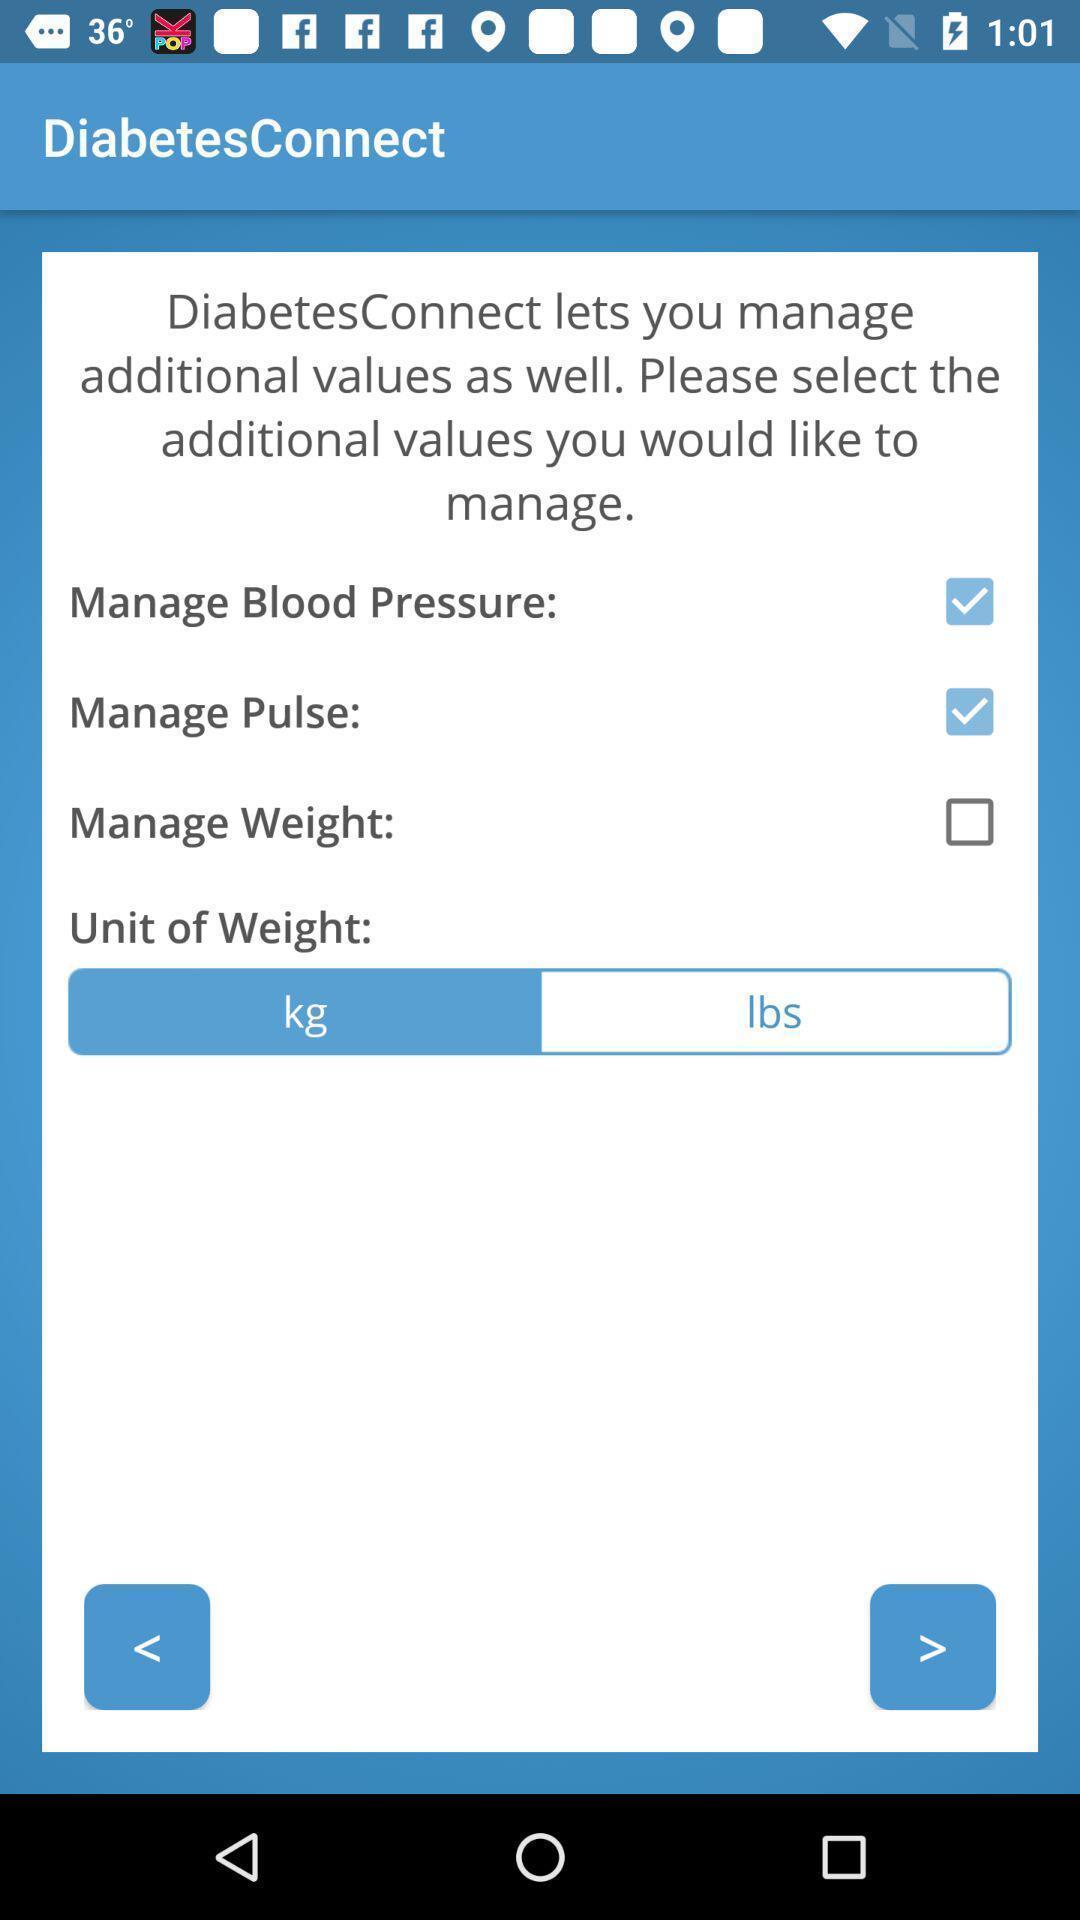Tell me about the visual elements in this screen capture. Starting page with settings in a healthcare app. 